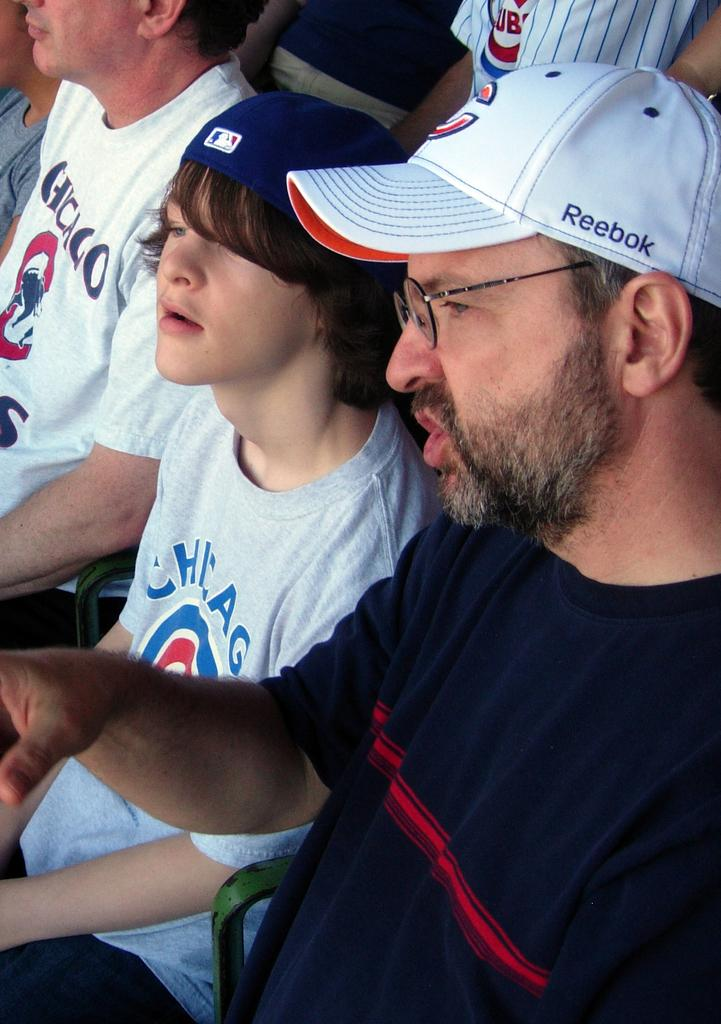<image>
Describe the image concisely. A man and a young teenage boy sitting in stadium seats wearing Chicago Cub T-shirts and hats. 